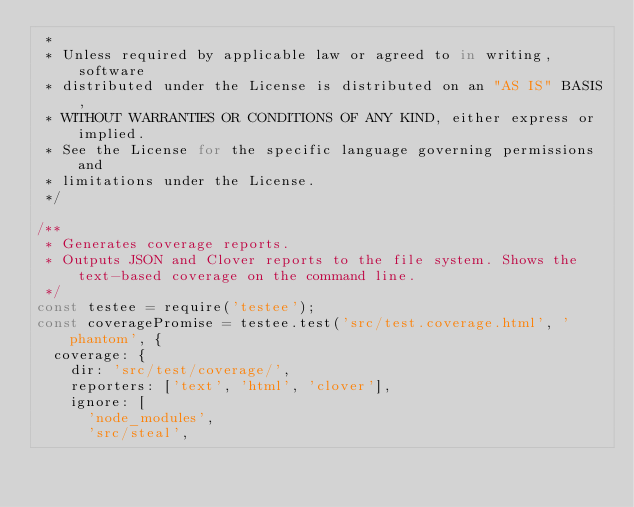Convert code to text. <code><loc_0><loc_0><loc_500><loc_500><_JavaScript_> * 
 * Unless required by applicable law or agreed to in writing, software
 * distributed under the License is distributed on an "AS IS" BASIS,
 * WITHOUT WARRANTIES OR CONDITIONS OF ANY KIND, either express or implied.
 * See the License for the specific language governing permissions and
 * limitations under the License.
 */

/**
 * Generates coverage reports.
 * Outputs JSON and Clover reports to the file system. Shows the text-based coverage on the command line.
 */
const testee = require('testee');
const coveragePromise = testee.test('src/test.coverage.html', 'phantom', {
  coverage: {
    dir: 'src/test/coverage/',
    reporters: ['text', 'html', 'clover'],
    ignore: [
      'node_modules',
      'src/steal',</code> 